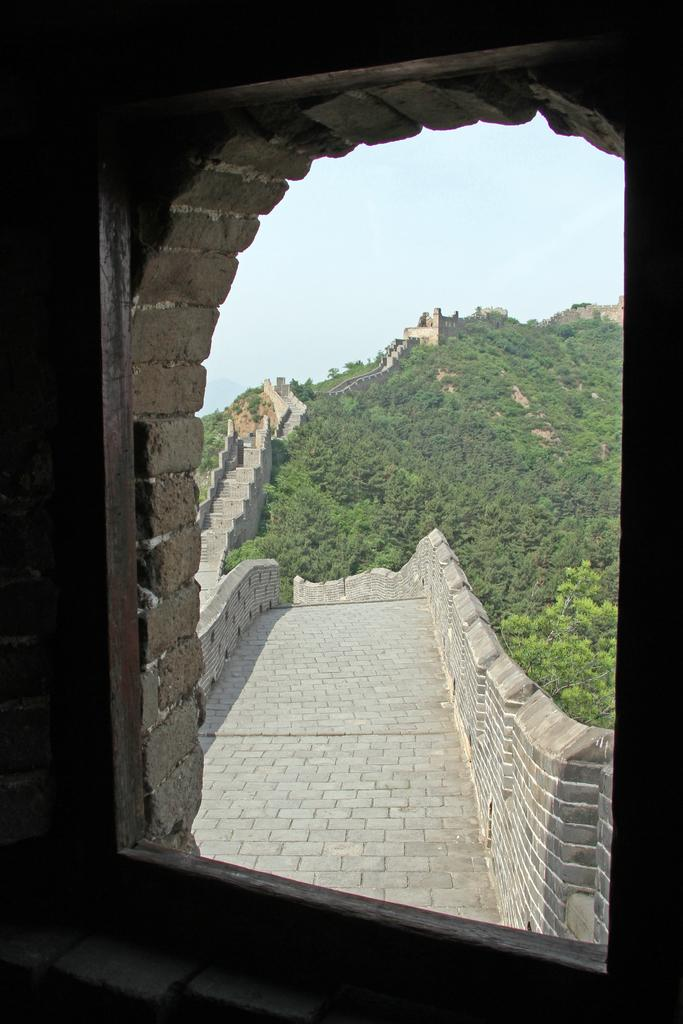What type of window is depicted in the image? The image contains a brick window. What can be seen through the window? The Great Wall of China is visible through the window. Are there any natural elements near the Great Wall of China in the image? Yes, there are trees near the Great Wall of China. Can you tell me how many goldfish are swimming in the ice near the window? There are no goldfish or ice present in the image; it features a brick window with the Great Wall of China visible through it and trees nearby. 